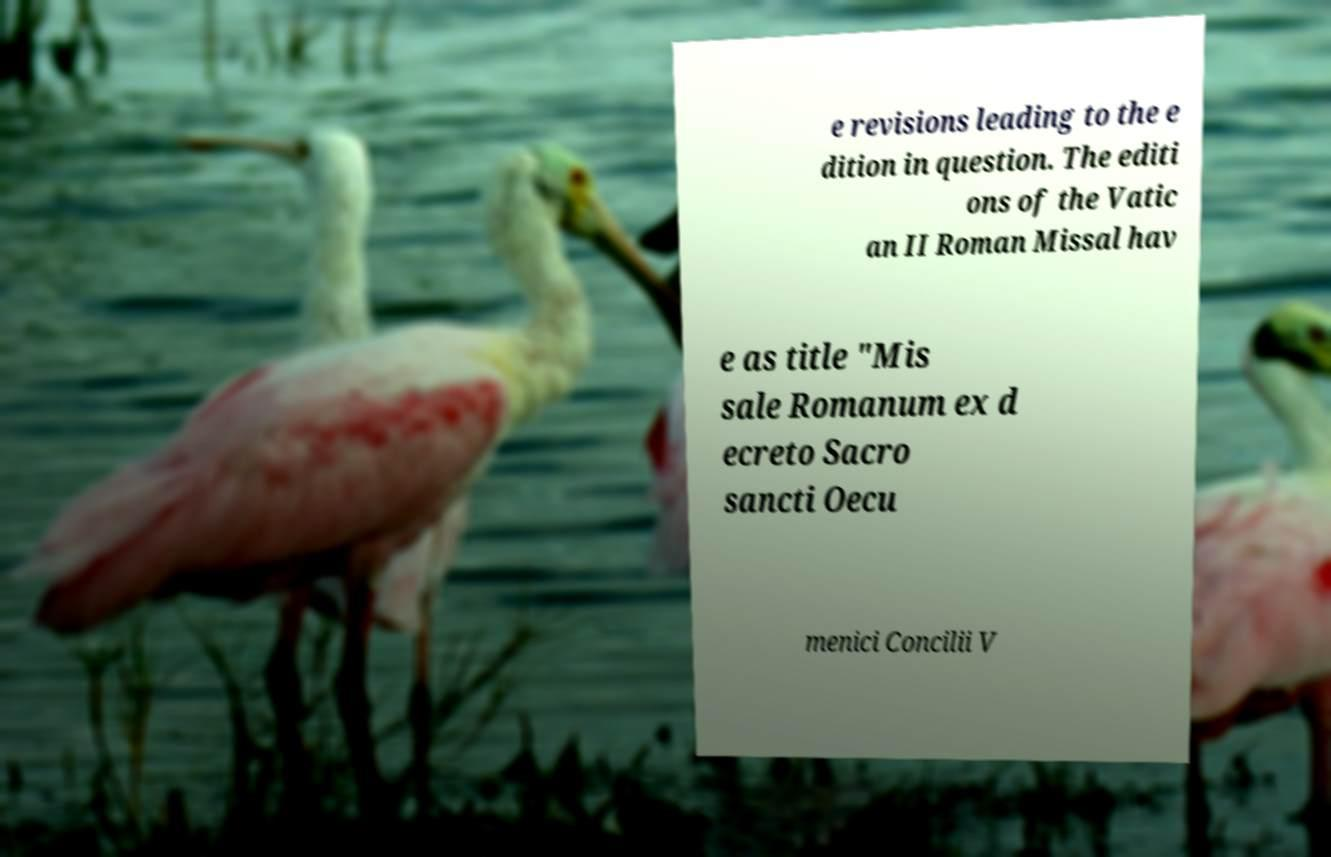Please read and relay the text visible in this image. What does it say? e revisions leading to the e dition in question. The editi ons of the Vatic an II Roman Missal hav e as title "Mis sale Romanum ex d ecreto Sacro sancti Oecu menici Concilii V 